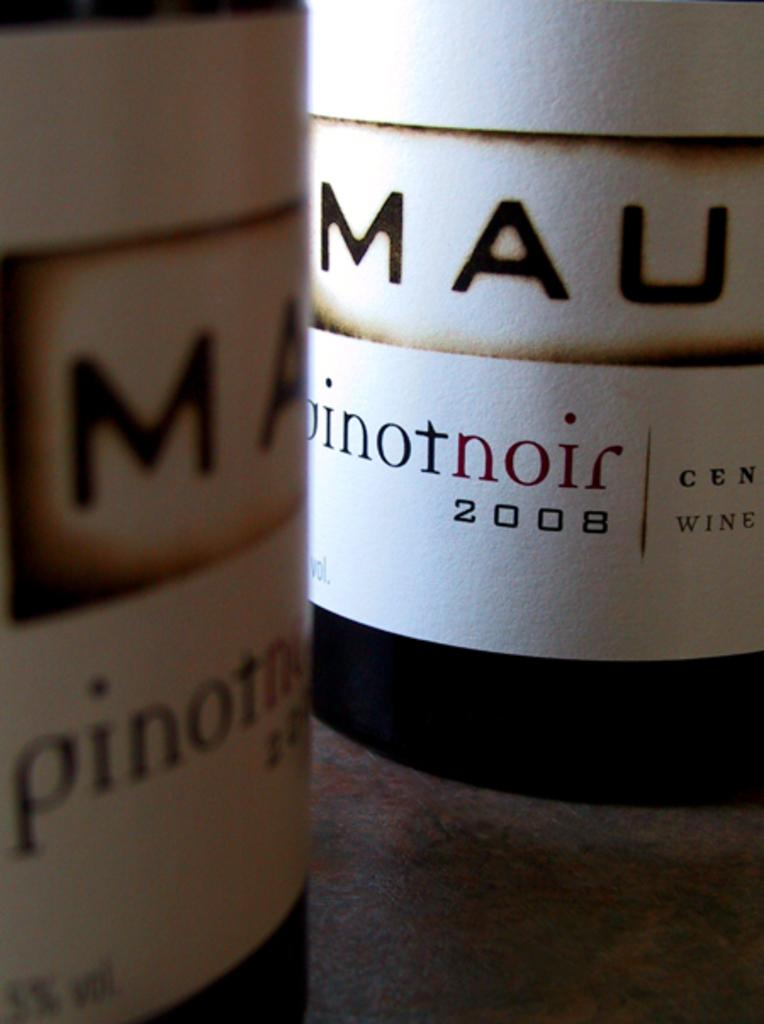<image>
Relay a brief, clear account of the picture shown. Two bottles of pinotnoir dated from 2008 on a table. 